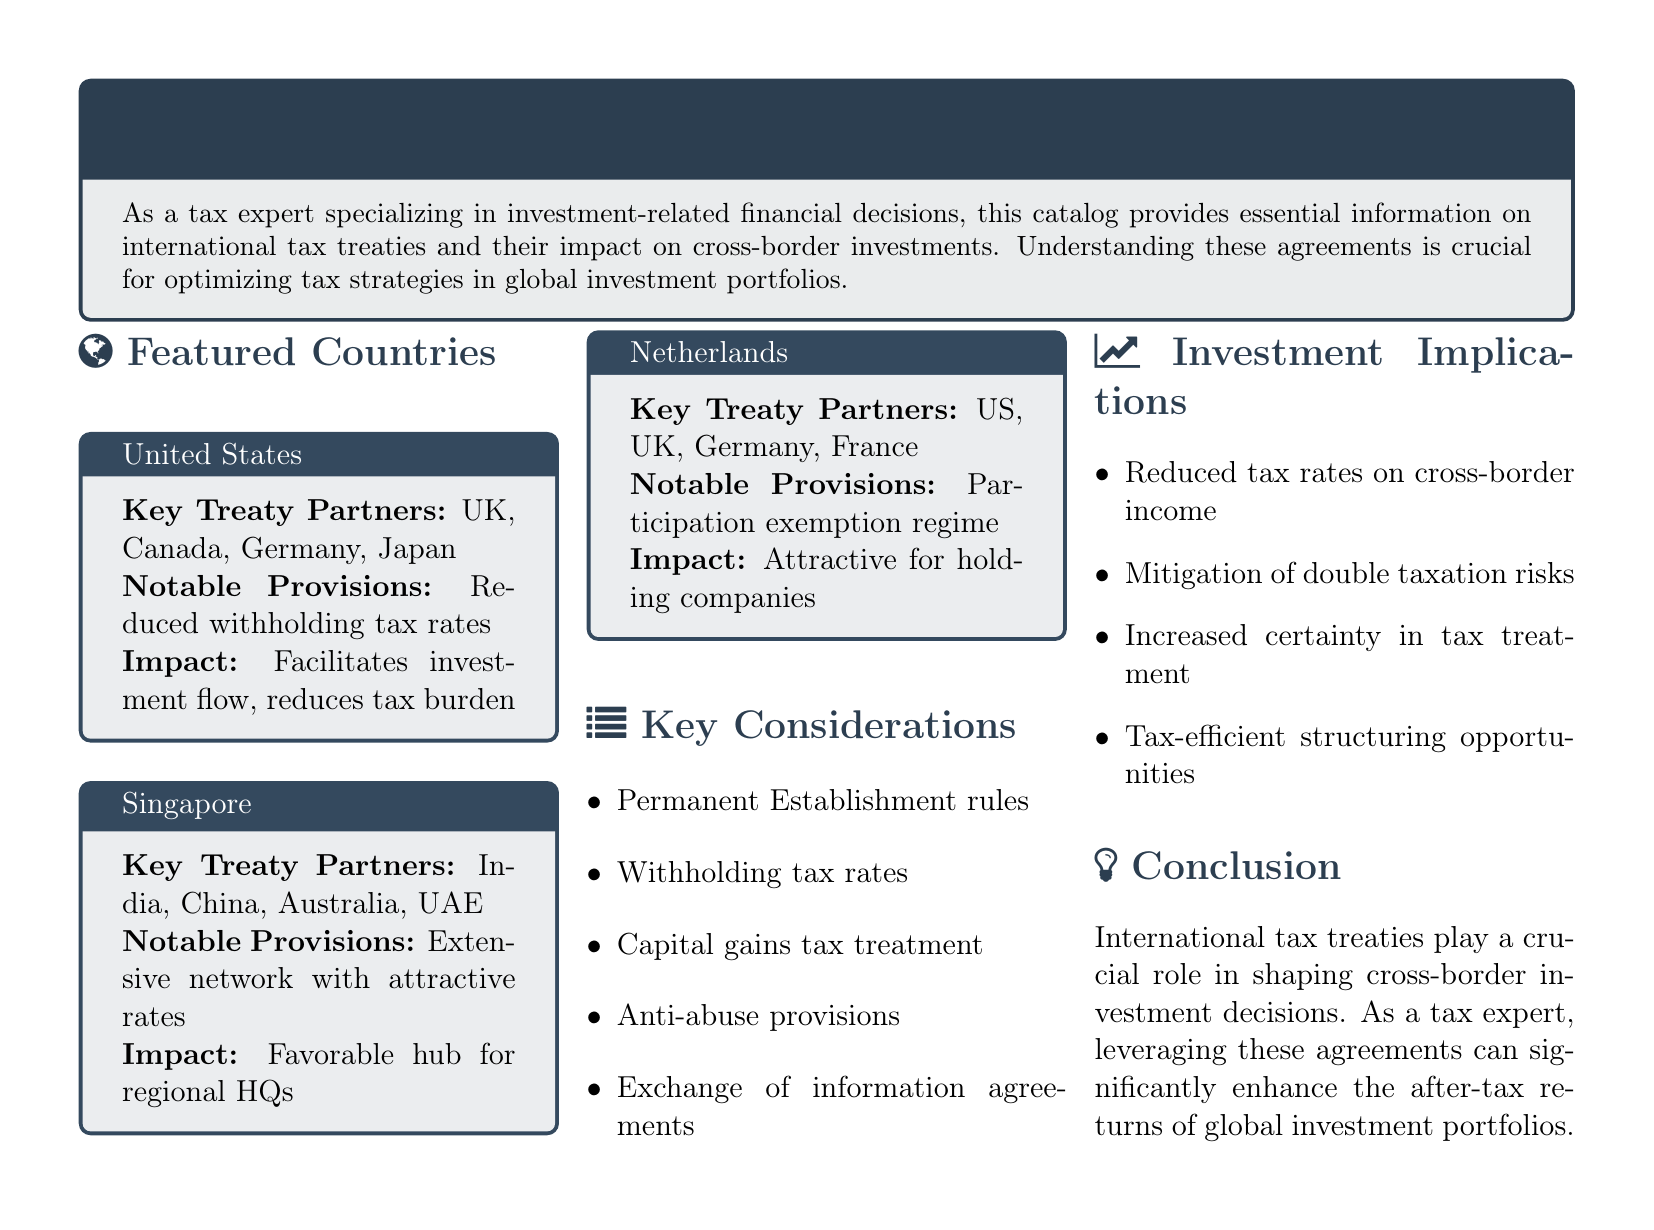What are the key treaty partners of the United States? The document lists the countries that have tax treaties with the United States as key treaty partners.
Answer: UK, Canada, Germany, Japan What is the notable provision for Singapore? The notable provision mentioned for Singapore relates to its extensive network and favorable rates for investment.
Answer: Extensive network with attractive rates What impact does the Netherlands provide for holding companies? The document states the impact associated with the key treaty partners for the Netherlands on holding companies.
Answer: Attractive for holding companies What is a key consideration in international tax treaties? The document outlines several factors that must be considered when evaluating international tax treaties.
Answer: Permanent Establishment rules What is one of the investment implications outlined in the document? The document lists multiple implications that can arise from international tax treaties affecting investments.
Answer: Reduced tax rates on cross-border income 